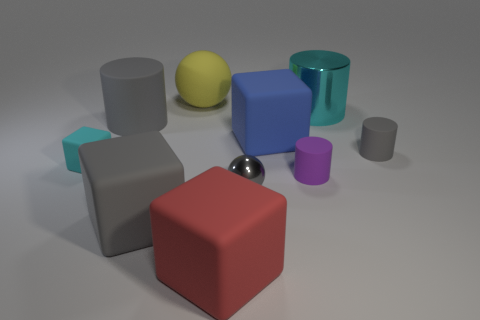What is the material of the cyan object that is the same shape as the blue thing?
Make the answer very short. Rubber. How big is the gray thing right of the big block behind the purple cylinder?
Your answer should be compact. Small. What color is the big metal cylinder?
Provide a short and direct response. Cyan. There is a gray cylinder that is to the left of the big cyan metallic cylinder; what number of gray rubber cylinders are behind it?
Ensure brevity in your answer.  0. There is a metal object that is behind the small cyan matte object; is there a gray cylinder to the left of it?
Your answer should be compact. Yes. There is a big blue thing; are there any large things in front of it?
Make the answer very short. Yes. Do the large rubber thing that is right of the red matte block and the tiny cyan matte thing have the same shape?
Provide a short and direct response. Yes. What number of red matte objects have the same shape as the blue object?
Provide a short and direct response. 1. Is there a red thing that has the same material as the big blue cube?
Your answer should be very brief. Yes. The large thing that is left of the big block to the left of the big yellow sphere is made of what material?
Provide a short and direct response. Rubber. 